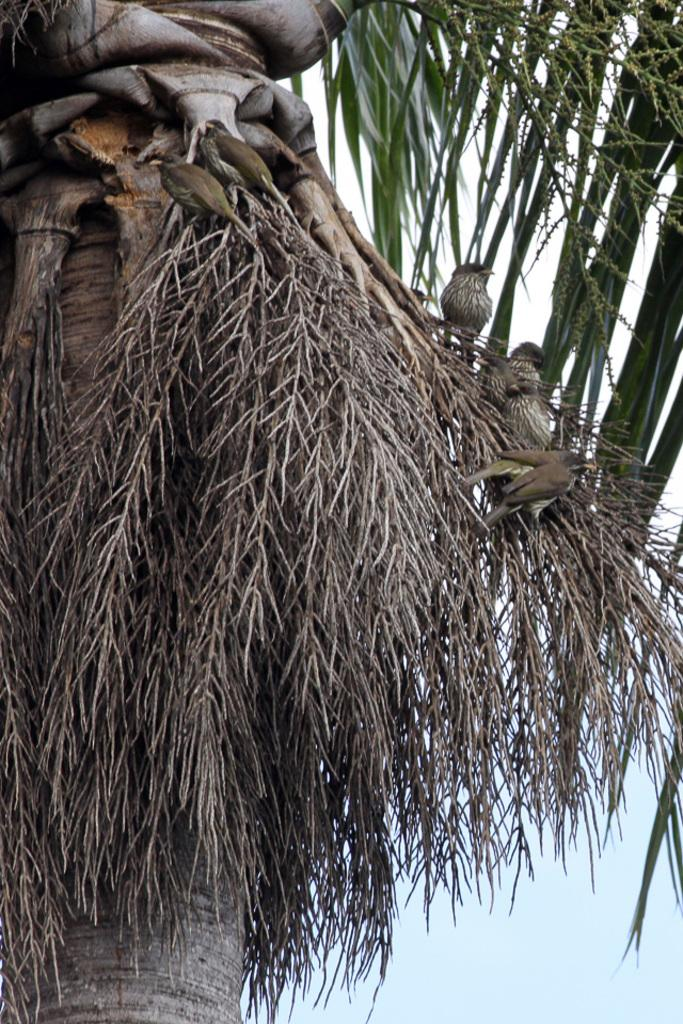What type of animals are on the tree in the image? There are birds on the tree in the image. What can be seen in the background of the image? The sky is visible in the background of the image. What is the color of the sky in the image? The sky is blue in color. What type of crayon is being used by the birds in the image? There are no crayons present in the image, and the birds are not using any crayons. 